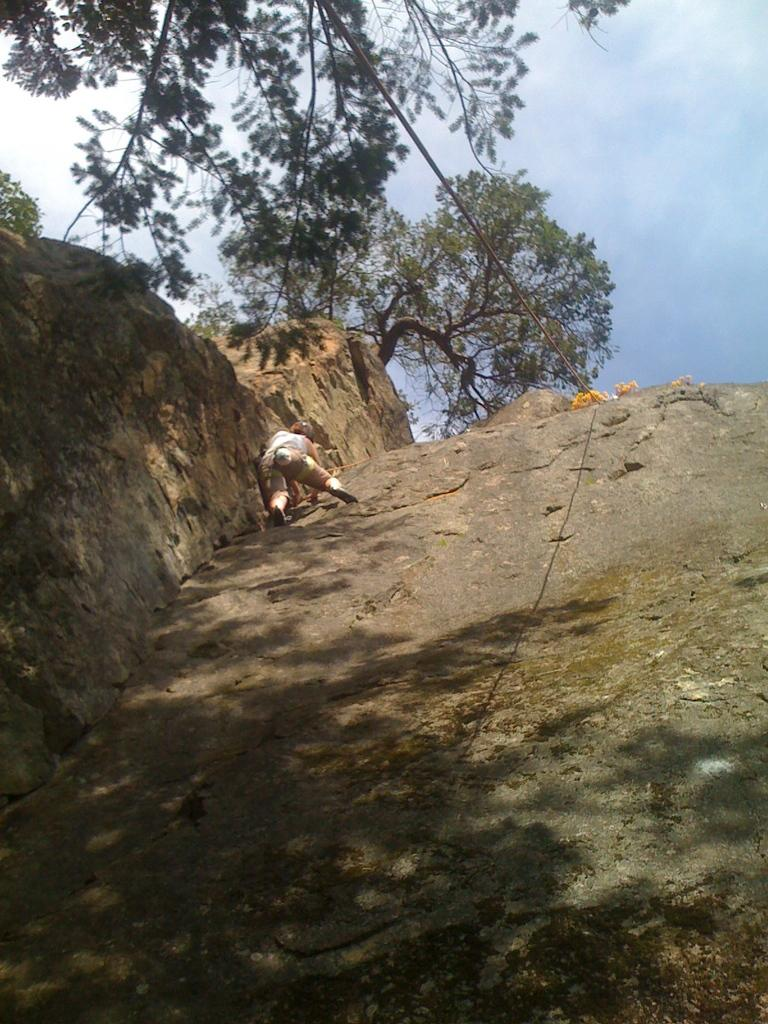What geographical feature is present in the image? There is a hill in the image. What is the person in the image doing? A person is climbing the hill. What can be found at the top of the hill? There is a tree on top of the hill. What can be seen in the distance in the image? The sky is visible in the background. What object is present that might be used for assistance or support? There is a rope in the image. What type of church can be seen in the image? There is no church present in the image; it features a hill, a person climbing the hill, a tree at the top, and a rope. What noise can be heard coming from the tree in the image? There is no noise present in the image, as it is a still photograph. 